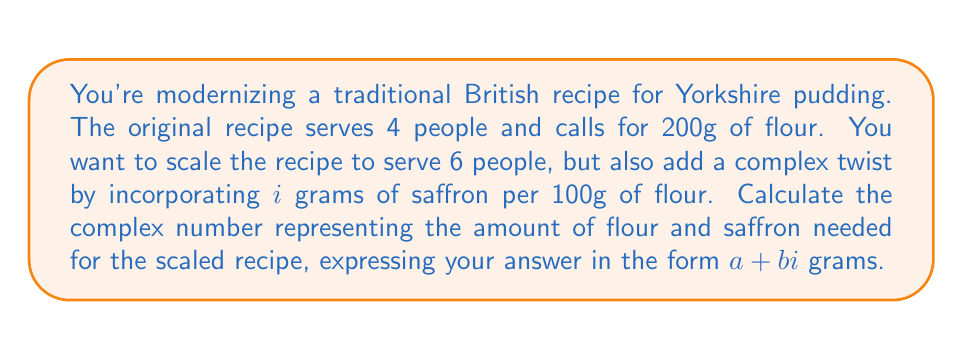Solve this math problem. Let's approach this step-by-step:

1) First, let's calculate the scaling factor:
   $\frac{6 \text{ people}}{4 \text{ people}} = 1.5$

2) Now, let's scale the flour amount:
   $200g \times 1.5 = 300g$ of flour for 6 people

3) We need to add $i$ grams of saffron per 100g of flour. For 300g of flour:
   $\frac{300g}{100g} \times i = 3i$ grams of saffron

4) The complex number representing the flour and saffron is the sum of the real part (flour) and the imaginary part (saffron):

   $300 + 3i$ grams

This complex number represents 300 grams of flour and $3i$ grams of saffron.
Answer: $300 + 3i$ grams 